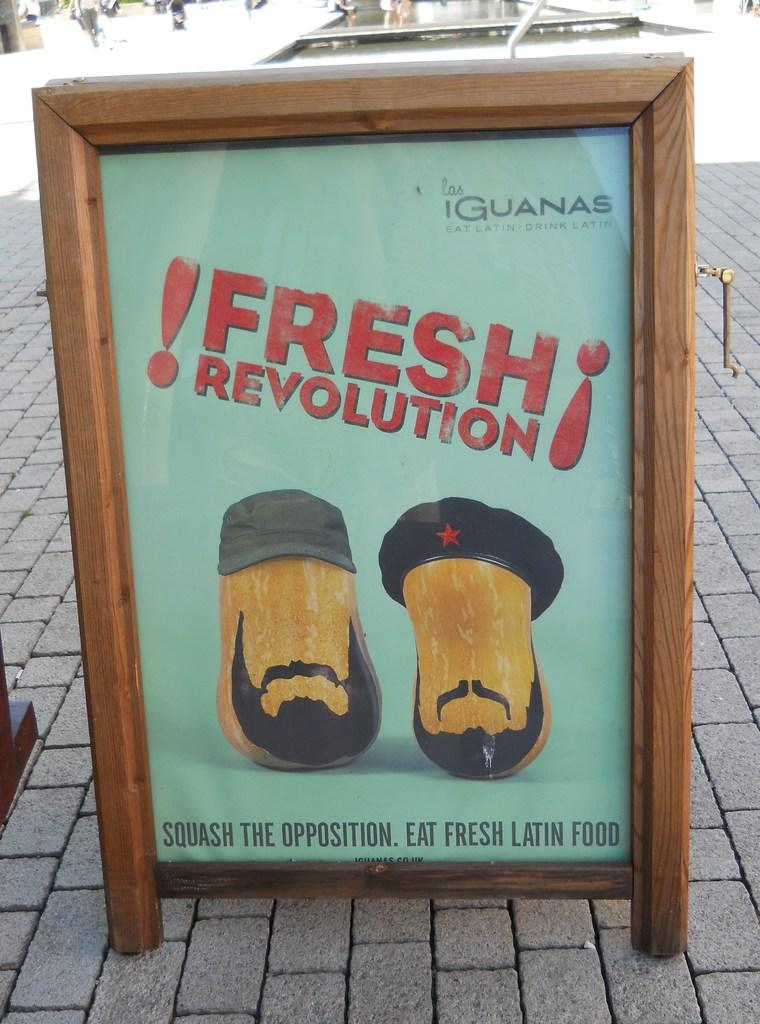What is placed on the footpath in the image? There is a hoarding on the footpath. Can you describe any other objects or features in the background of the image? There are other objects in the background, but their specific details are not mentioned in the provided facts. How many oranges are being sold on the sidewalk in the image? There is no mention of oranges or a sidewalk in the provided facts, so we cannot answer this question. 